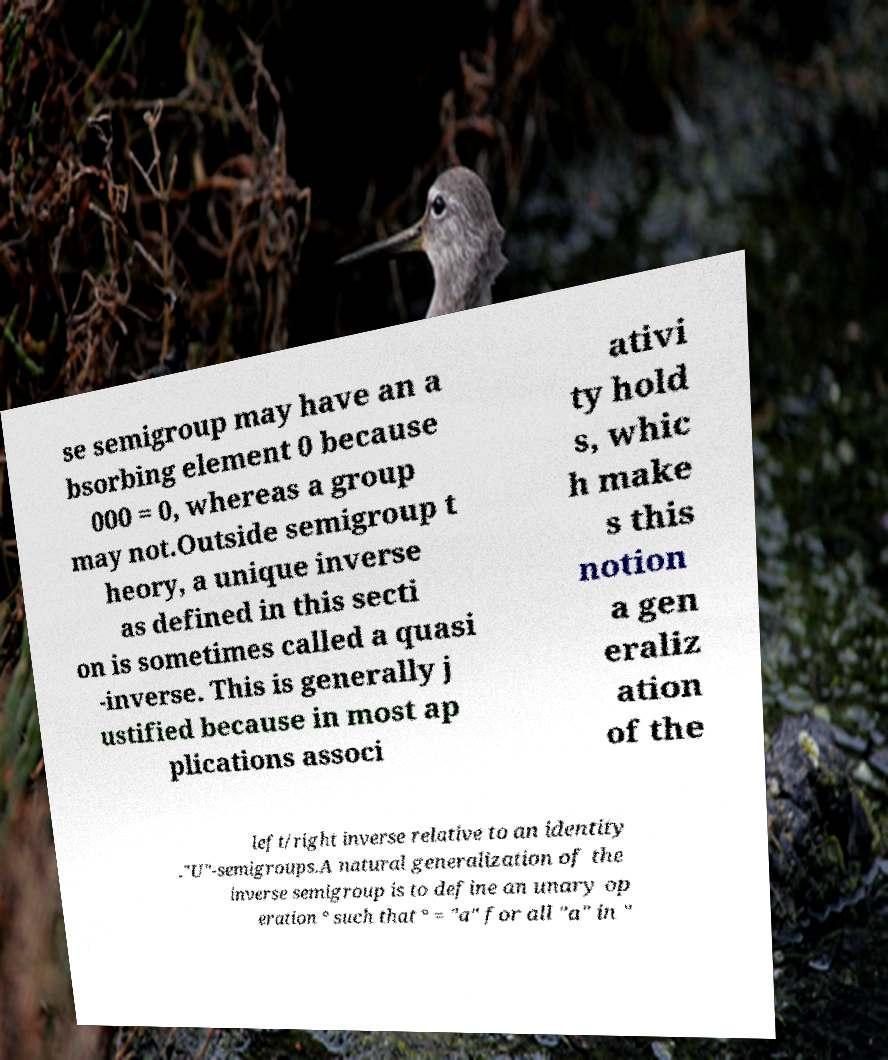For documentation purposes, I need the text within this image transcribed. Could you provide that? se semigroup may have an a bsorbing element 0 because 000 = 0, whereas a group may not.Outside semigroup t heory, a unique inverse as defined in this secti on is sometimes called a quasi -inverse. This is generally j ustified because in most ap plications associ ativi ty hold s, whic h make s this notion a gen eraliz ation of the left/right inverse relative to an identity ."U"-semigroups.A natural generalization of the inverse semigroup is to define an unary op eration ° such that ° = "a" for all "a" in " 